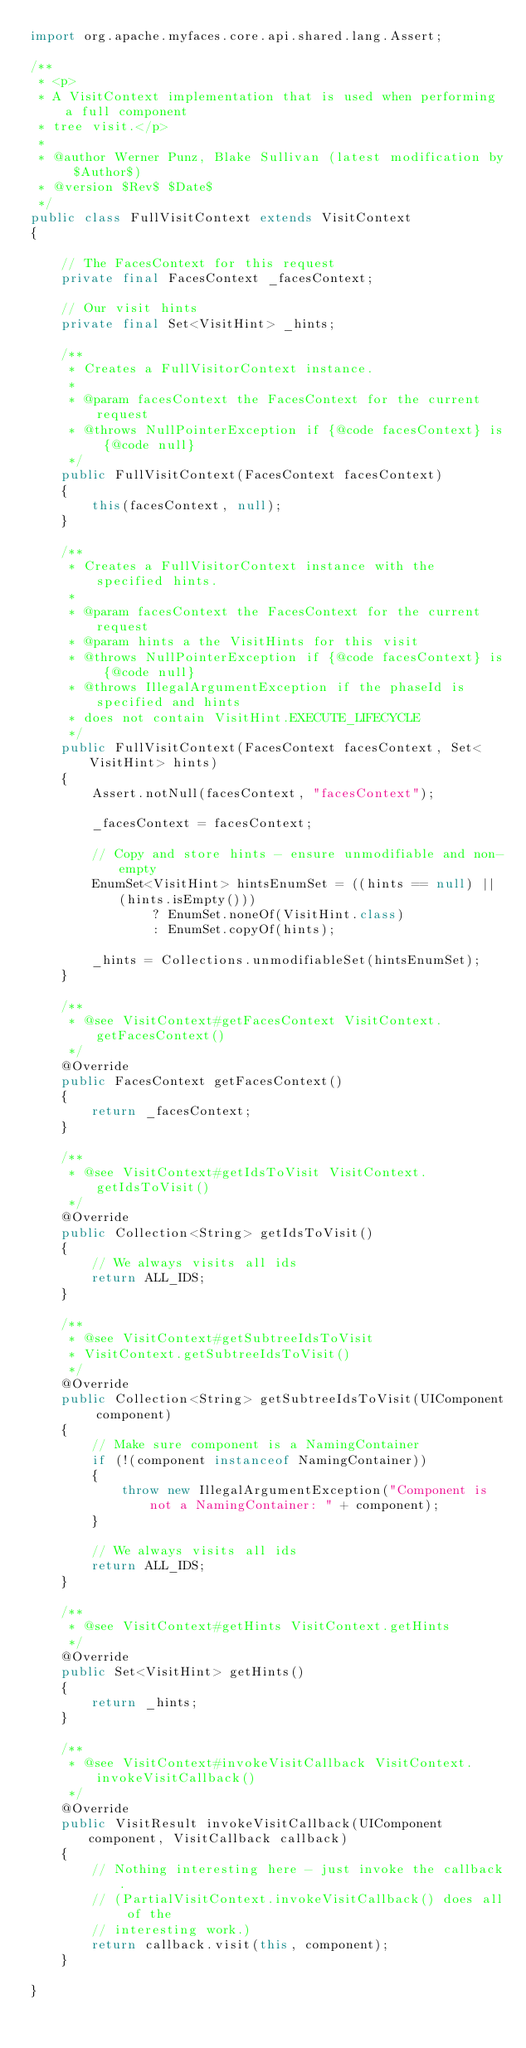<code> <loc_0><loc_0><loc_500><loc_500><_Java_>import org.apache.myfaces.core.api.shared.lang.Assert;

/**
 * <p>
 * A VisitContext implementation that is used when performing a full component
 * tree visit.</p>
 *
 * @author Werner Punz, Blake Sullivan (latest modification by $Author$)
 * @version $Rev$ $Date$
 */
public class FullVisitContext extends VisitContext
{

    // The FacesContext for this request
    private final FacesContext _facesContext;

    // Our visit hints
    private final Set<VisitHint> _hints;
    
    /**
     * Creates a FullVisitorContext instance.
     *
     * @param facesContext the FacesContext for the current request
     * @throws NullPointerException if {@code facesContext} is {@code null}
     */
    public FullVisitContext(FacesContext facesContext)
    {
        this(facesContext, null);
    }

    /**
     * Creates a FullVisitorContext instance with the specified hints.
     *
     * @param facesContext the FacesContext for the current request
     * @param hints a the VisitHints for this visit
     * @throws NullPointerException if {@code facesContext} is {@code null}
     * @throws IllegalArgumentException if the phaseId is specified and hints
     * does not contain VisitHint.EXECUTE_LIFECYCLE
     */
    public FullVisitContext(FacesContext facesContext, Set<VisitHint> hints)
    {
        Assert.notNull(facesContext, "facesContext");

        _facesContext = facesContext;

        // Copy and store hints - ensure unmodifiable and non-empty
        EnumSet<VisitHint> hintsEnumSet = ((hints == null) || (hints.isEmpty()))
                ? EnumSet.noneOf(VisitHint.class)
                : EnumSet.copyOf(hints);

        _hints = Collections.unmodifiableSet(hintsEnumSet);
    }

    /**
     * @see VisitContext#getFacesContext VisitContext.getFacesContext()
     */
    @Override
    public FacesContext getFacesContext()
    {
        return _facesContext;
    }

    /**
     * @see VisitContext#getIdsToVisit VisitContext.getIdsToVisit()
     */
    @Override
    public Collection<String> getIdsToVisit()
    {
        // We always visits all ids
        return ALL_IDS;
    }

    /**
     * @see VisitContext#getSubtreeIdsToVisit
     * VisitContext.getSubtreeIdsToVisit()
     */
    @Override
    public Collection<String> getSubtreeIdsToVisit(UIComponent component)
    {
        // Make sure component is a NamingContainer
        if (!(component instanceof NamingContainer))
        {
            throw new IllegalArgumentException("Component is not a NamingContainer: " + component);
        }

        // We always visits all ids
        return ALL_IDS;
    }

    /**
     * @see VisitContext#getHints VisitContext.getHints
     */
    @Override
    public Set<VisitHint> getHints()
    {
        return _hints;
    }

    /**
     * @see VisitContext#invokeVisitCallback VisitContext.invokeVisitCallback()
     */
    @Override
    public VisitResult invokeVisitCallback(UIComponent component, VisitCallback callback)
    {
        // Nothing interesting here - just invoke the callback.
        // (PartialVisitContext.invokeVisitCallback() does all of the 
        // interesting work.)
        return callback.visit(this, component);
    }

}
</code> 